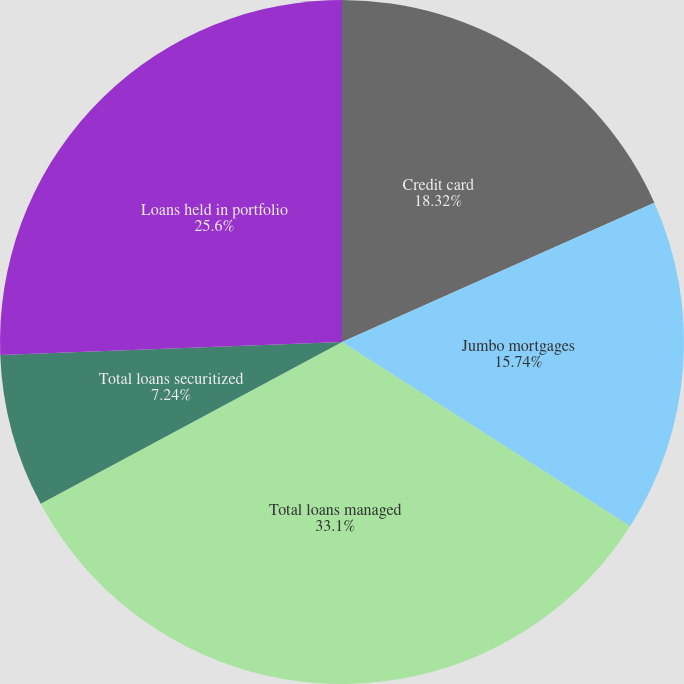Convert chart. <chart><loc_0><loc_0><loc_500><loc_500><pie_chart><fcel>Credit card<fcel>Jumbo mortgages<fcel>Total loans managed<fcel>Total loans securitized<fcel>Loans held in portfolio<nl><fcel>18.32%<fcel>15.74%<fcel>33.1%<fcel>7.24%<fcel>25.6%<nl></chart> 